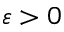Convert formula to latex. <formula><loc_0><loc_0><loc_500><loc_500>\varepsilon > 0</formula> 